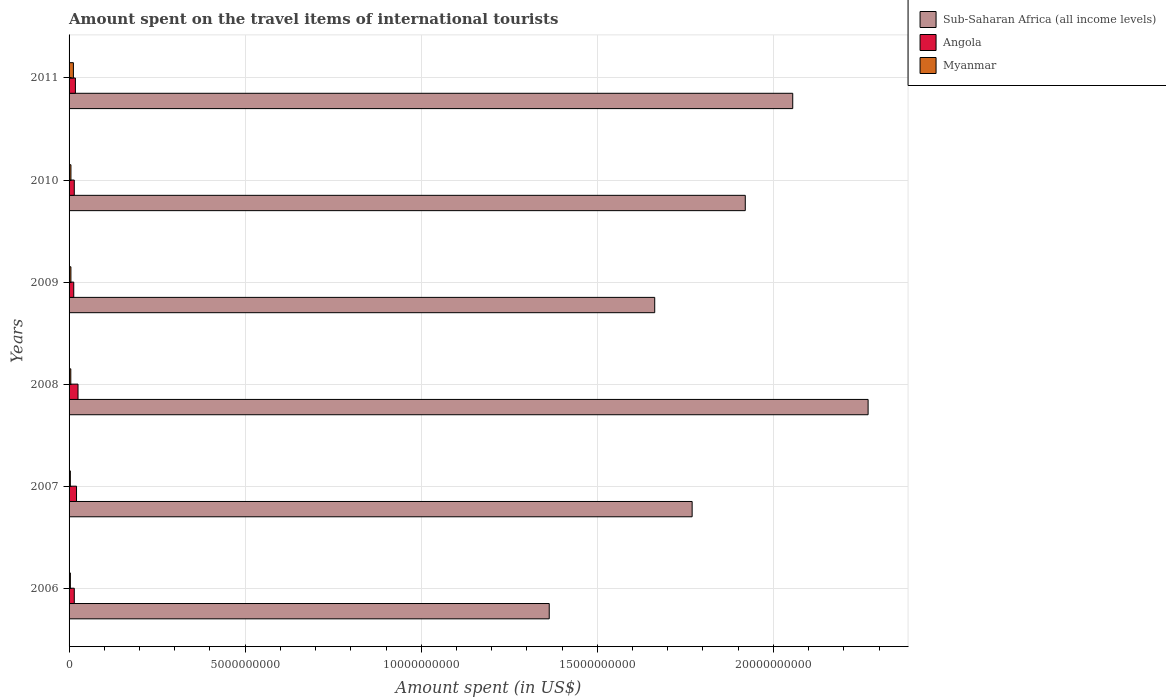How many different coloured bars are there?
Offer a very short reply. 3. How many groups of bars are there?
Ensure brevity in your answer.  6. How many bars are there on the 3rd tick from the top?
Ensure brevity in your answer.  3. How many bars are there on the 1st tick from the bottom?
Offer a very short reply. 3. What is the label of the 6th group of bars from the top?
Provide a short and direct response. 2006. In how many cases, is the number of bars for a given year not equal to the number of legend labels?
Offer a terse response. 0. What is the amount spent on the travel items of international tourists in Sub-Saharan Africa (all income levels) in 2008?
Your answer should be compact. 2.27e+1. Across all years, what is the maximum amount spent on the travel items of international tourists in Sub-Saharan Africa (all income levels)?
Your answer should be very brief. 2.27e+1. Across all years, what is the minimum amount spent on the travel items of international tourists in Sub-Saharan Africa (all income levels)?
Ensure brevity in your answer.  1.36e+1. In which year was the amount spent on the travel items of international tourists in Angola maximum?
Give a very brief answer. 2008. In which year was the amount spent on the travel items of international tourists in Sub-Saharan Africa (all income levels) minimum?
Provide a succinct answer. 2006. What is the total amount spent on the travel items of international tourists in Angola in the graph?
Ensure brevity in your answer.  1.08e+09. What is the difference between the amount spent on the travel items of international tourists in Angola in 2006 and that in 2011?
Give a very brief answer. -3.20e+07. What is the difference between the amount spent on the travel items of international tourists in Myanmar in 2011 and the amount spent on the travel items of international tourists in Angola in 2007?
Give a very brief answer. -8.90e+07. What is the average amount spent on the travel items of international tourists in Sub-Saharan Africa (all income levels) per year?
Your answer should be compact. 1.84e+1. In the year 2009, what is the difference between the amount spent on the travel items of international tourists in Sub-Saharan Africa (all income levels) and amount spent on the travel items of international tourists in Angola?
Your answer should be very brief. 1.65e+1. What is the ratio of the amount spent on the travel items of international tourists in Angola in 2008 to that in 2009?
Keep it short and to the point. 1.91. Is the amount spent on the travel items of international tourists in Sub-Saharan Africa (all income levels) in 2006 less than that in 2007?
Offer a terse response. Yes. What is the difference between the highest and the second highest amount spent on the travel items of international tourists in Angola?
Keep it short and to the point. 4.20e+07. What is the difference between the highest and the lowest amount spent on the travel items of international tourists in Angola?
Offer a very short reply. 1.21e+08. In how many years, is the amount spent on the travel items of international tourists in Angola greater than the average amount spent on the travel items of international tourists in Angola taken over all years?
Give a very brief answer. 3. What does the 3rd bar from the top in 2008 represents?
Give a very brief answer. Sub-Saharan Africa (all income levels). What does the 2nd bar from the bottom in 2011 represents?
Make the answer very short. Angola. Is it the case that in every year, the sum of the amount spent on the travel items of international tourists in Myanmar and amount spent on the travel items of international tourists in Angola is greater than the amount spent on the travel items of international tourists in Sub-Saharan Africa (all income levels)?
Keep it short and to the point. No. How many bars are there?
Make the answer very short. 18. Are all the bars in the graph horizontal?
Make the answer very short. Yes. What is the difference between two consecutive major ticks on the X-axis?
Provide a succinct answer. 5.00e+09. Are the values on the major ticks of X-axis written in scientific E-notation?
Your answer should be very brief. No. Does the graph contain any zero values?
Offer a very short reply. No. How many legend labels are there?
Make the answer very short. 3. What is the title of the graph?
Your answer should be very brief. Amount spent on the travel items of international tourists. What is the label or title of the X-axis?
Give a very brief answer. Amount spent (in US$). What is the label or title of the Y-axis?
Provide a short and direct response. Years. What is the Amount spent (in US$) of Sub-Saharan Africa (all income levels) in 2006?
Keep it short and to the point. 1.36e+1. What is the Amount spent (in US$) in Angola in 2006?
Your response must be concise. 1.48e+08. What is the Amount spent (in US$) of Myanmar in 2006?
Your answer should be compact. 3.70e+07. What is the Amount spent (in US$) of Sub-Saharan Africa (all income levels) in 2007?
Your answer should be compact. 1.77e+1. What is the Amount spent (in US$) of Angola in 2007?
Offer a terse response. 2.12e+08. What is the Amount spent (in US$) of Myanmar in 2007?
Provide a short and direct response. 3.60e+07. What is the Amount spent (in US$) of Sub-Saharan Africa (all income levels) in 2008?
Provide a short and direct response. 2.27e+1. What is the Amount spent (in US$) in Angola in 2008?
Your response must be concise. 2.54e+08. What is the Amount spent (in US$) of Myanmar in 2008?
Give a very brief answer. 4.90e+07. What is the Amount spent (in US$) in Sub-Saharan Africa (all income levels) in 2009?
Ensure brevity in your answer.  1.66e+1. What is the Amount spent (in US$) of Angola in 2009?
Ensure brevity in your answer.  1.33e+08. What is the Amount spent (in US$) in Myanmar in 2009?
Give a very brief answer. 5.20e+07. What is the Amount spent (in US$) in Sub-Saharan Africa (all income levels) in 2010?
Keep it short and to the point. 1.92e+1. What is the Amount spent (in US$) of Angola in 2010?
Ensure brevity in your answer.  1.48e+08. What is the Amount spent (in US$) of Myanmar in 2010?
Your response must be concise. 5.30e+07. What is the Amount spent (in US$) in Sub-Saharan Africa (all income levels) in 2011?
Give a very brief answer. 2.06e+1. What is the Amount spent (in US$) in Angola in 2011?
Your answer should be compact. 1.80e+08. What is the Amount spent (in US$) in Myanmar in 2011?
Provide a succinct answer. 1.23e+08. Across all years, what is the maximum Amount spent (in US$) in Sub-Saharan Africa (all income levels)?
Offer a very short reply. 2.27e+1. Across all years, what is the maximum Amount spent (in US$) of Angola?
Your response must be concise. 2.54e+08. Across all years, what is the maximum Amount spent (in US$) in Myanmar?
Provide a succinct answer. 1.23e+08. Across all years, what is the minimum Amount spent (in US$) of Sub-Saharan Africa (all income levels)?
Give a very brief answer. 1.36e+1. Across all years, what is the minimum Amount spent (in US$) of Angola?
Your answer should be very brief. 1.33e+08. Across all years, what is the minimum Amount spent (in US$) of Myanmar?
Make the answer very short. 3.60e+07. What is the total Amount spent (in US$) of Sub-Saharan Africa (all income levels) in the graph?
Offer a terse response. 1.10e+11. What is the total Amount spent (in US$) in Angola in the graph?
Offer a terse response. 1.08e+09. What is the total Amount spent (in US$) of Myanmar in the graph?
Offer a very short reply. 3.50e+08. What is the difference between the Amount spent (in US$) in Sub-Saharan Africa (all income levels) in 2006 and that in 2007?
Your response must be concise. -4.06e+09. What is the difference between the Amount spent (in US$) in Angola in 2006 and that in 2007?
Offer a very short reply. -6.40e+07. What is the difference between the Amount spent (in US$) of Sub-Saharan Africa (all income levels) in 2006 and that in 2008?
Offer a very short reply. -9.06e+09. What is the difference between the Amount spent (in US$) in Angola in 2006 and that in 2008?
Make the answer very short. -1.06e+08. What is the difference between the Amount spent (in US$) in Myanmar in 2006 and that in 2008?
Your answer should be very brief. -1.20e+07. What is the difference between the Amount spent (in US$) in Sub-Saharan Africa (all income levels) in 2006 and that in 2009?
Your answer should be very brief. -3.00e+09. What is the difference between the Amount spent (in US$) in Angola in 2006 and that in 2009?
Keep it short and to the point. 1.50e+07. What is the difference between the Amount spent (in US$) of Myanmar in 2006 and that in 2009?
Provide a succinct answer. -1.50e+07. What is the difference between the Amount spent (in US$) in Sub-Saharan Africa (all income levels) in 2006 and that in 2010?
Provide a succinct answer. -5.57e+09. What is the difference between the Amount spent (in US$) in Angola in 2006 and that in 2010?
Provide a succinct answer. 0. What is the difference between the Amount spent (in US$) of Myanmar in 2006 and that in 2010?
Offer a terse response. -1.60e+07. What is the difference between the Amount spent (in US$) in Sub-Saharan Africa (all income levels) in 2006 and that in 2011?
Offer a very short reply. -6.92e+09. What is the difference between the Amount spent (in US$) of Angola in 2006 and that in 2011?
Your answer should be very brief. -3.20e+07. What is the difference between the Amount spent (in US$) in Myanmar in 2006 and that in 2011?
Offer a very short reply. -8.60e+07. What is the difference between the Amount spent (in US$) in Sub-Saharan Africa (all income levels) in 2007 and that in 2008?
Your answer should be compact. -5.00e+09. What is the difference between the Amount spent (in US$) in Angola in 2007 and that in 2008?
Provide a short and direct response. -4.20e+07. What is the difference between the Amount spent (in US$) of Myanmar in 2007 and that in 2008?
Make the answer very short. -1.30e+07. What is the difference between the Amount spent (in US$) of Sub-Saharan Africa (all income levels) in 2007 and that in 2009?
Your answer should be compact. 1.06e+09. What is the difference between the Amount spent (in US$) in Angola in 2007 and that in 2009?
Make the answer very short. 7.90e+07. What is the difference between the Amount spent (in US$) of Myanmar in 2007 and that in 2009?
Offer a terse response. -1.60e+07. What is the difference between the Amount spent (in US$) in Sub-Saharan Africa (all income levels) in 2007 and that in 2010?
Offer a very short reply. -1.51e+09. What is the difference between the Amount spent (in US$) in Angola in 2007 and that in 2010?
Make the answer very short. 6.40e+07. What is the difference between the Amount spent (in US$) in Myanmar in 2007 and that in 2010?
Provide a short and direct response. -1.70e+07. What is the difference between the Amount spent (in US$) in Sub-Saharan Africa (all income levels) in 2007 and that in 2011?
Offer a very short reply. -2.86e+09. What is the difference between the Amount spent (in US$) of Angola in 2007 and that in 2011?
Provide a succinct answer. 3.20e+07. What is the difference between the Amount spent (in US$) of Myanmar in 2007 and that in 2011?
Offer a terse response. -8.70e+07. What is the difference between the Amount spent (in US$) in Sub-Saharan Africa (all income levels) in 2008 and that in 2009?
Offer a very short reply. 6.06e+09. What is the difference between the Amount spent (in US$) in Angola in 2008 and that in 2009?
Ensure brevity in your answer.  1.21e+08. What is the difference between the Amount spent (in US$) of Sub-Saharan Africa (all income levels) in 2008 and that in 2010?
Give a very brief answer. 3.49e+09. What is the difference between the Amount spent (in US$) in Angola in 2008 and that in 2010?
Your answer should be very brief. 1.06e+08. What is the difference between the Amount spent (in US$) in Myanmar in 2008 and that in 2010?
Make the answer very short. -4.00e+06. What is the difference between the Amount spent (in US$) in Sub-Saharan Africa (all income levels) in 2008 and that in 2011?
Your answer should be very brief. 2.14e+09. What is the difference between the Amount spent (in US$) of Angola in 2008 and that in 2011?
Offer a terse response. 7.40e+07. What is the difference between the Amount spent (in US$) of Myanmar in 2008 and that in 2011?
Your answer should be compact. -7.40e+07. What is the difference between the Amount spent (in US$) of Sub-Saharan Africa (all income levels) in 2009 and that in 2010?
Offer a very short reply. -2.57e+09. What is the difference between the Amount spent (in US$) of Angola in 2009 and that in 2010?
Provide a short and direct response. -1.50e+07. What is the difference between the Amount spent (in US$) of Sub-Saharan Africa (all income levels) in 2009 and that in 2011?
Offer a terse response. -3.92e+09. What is the difference between the Amount spent (in US$) in Angola in 2009 and that in 2011?
Provide a succinct answer. -4.70e+07. What is the difference between the Amount spent (in US$) of Myanmar in 2009 and that in 2011?
Make the answer very short. -7.10e+07. What is the difference between the Amount spent (in US$) of Sub-Saharan Africa (all income levels) in 2010 and that in 2011?
Your response must be concise. -1.35e+09. What is the difference between the Amount spent (in US$) in Angola in 2010 and that in 2011?
Offer a very short reply. -3.20e+07. What is the difference between the Amount spent (in US$) in Myanmar in 2010 and that in 2011?
Offer a terse response. -7.00e+07. What is the difference between the Amount spent (in US$) of Sub-Saharan Africa (all income levels) in 2006 and the Amount spent (in US$) of Angola in 2007?
Provide a succinct answer. 1.34e+1. What is the difference between the Amount spent (in US$) of Sub-Saharan Africa (all income levels) in 2006 and the Amount spent (in US$) of Myanmar in 2007?
Offer a very short reply. 1.36e+1. What is the difference between the Amount spent (in US$) in Angola in 2006 and the Amount spent (in US$) in Myanmar in 2007?
Your response must be concise. 1.12e+08. What is the difference between the Amount spent (in US$) in Sub-Saharan Africa (all income levels) in 2006 and the Amount spent (in US$) in Angola in 2008?
Provide a short and direct response. 1.34e+1. What is the difference between the Amount spent (in US$) in Sub-Saharan Africa (all income levels) in 2006 and the Amount spent (in US$) in Myanmar in 2008?
Offer a terse response. 1.36e+1. What is the difference between the Amount spent (in US$) of Angola in 2006 and the Amount spent (in US$) of Myanmar in 2008?
Make the answer very short. 9.90e+07. What is the difference between the Amount spent (in US$) in Sub-Saharan Africa (all income levels) in 2006 and the Amount spent (in US$) in Angola in 2009?
Make the answer very short. 1.35e+1. What is the difference between the Amount spent (in US$) in Sub-Saharan Africa (all income levels) in 2006 and the Amount spent (in US$) in Myanmar in 2009?
Provide a succinct answer. 1.36e+1. What is the difference between the Amount spent (in US$) of Angola in 2006 and the Amount spent (in US$) of Myanmar in 2009?
Your answer should be very brief. 9.60e+07. What is the difference between the Amount spent (in US$) in Sub-Saharan Africa (all income levels) in 2006 and the Amount spent (in US$) in Angola in 2010?
Keep it short and to the point. 1.35e+1. What is the difference between the Amount spent (in US$) in Sub-Saharan Africa (all income levels) in 2006 and the Amount spent (in US$) in Myanmar in 2010?
Make the answer very short. 1.36e+1. What is the difference between the Amount spent (in US$) of Angola in 2006 and the Amount spent (in US$) of Myanmar in 2010?
Give a very brief answer. 9.50e+07. What is the difference between the Amount spent (in US$) in Sub-Saharan Africa (all income levels) in 2006 and the Amount spent (in US$) in Angola in 2011?
Your answer should be very brief. 1.35e+1. What is the difference between the Amount spent (in US$) in Sub-Saharan Africa (all income levels) in 2006 and the Amount spent (in US$) in Myanmar in 2011?
Provide a succinct answer. 1.35e+1. What is the difference between the Amount spent (in US$) of Angola in 2006 and the Amount spent (in US$) of Myanmar in 2011?
Give a very brief answer. 2.50e+07. What is the difference between the Amount spent (in US$) in Sub-Saharan Africa (all income levels) in 2007 and the Amount spent (in US$) in Angola in 2008?
Provide a short and direct response. 1.74e+1. What is the difference between the Amount spent (in US$) in Sub-Saharan Africa (all income levels) in 2007 and the Amount spent (in US$) in Myanmar in 2008?
Offer a terse response. 1.76e+1. What is the difference between the Amount spent (in US$) of Angola in 2007 and the Amount spent (in US$) of Myanmar in 2008?
Give a very brief answer. 1.63e+08. What is the difference between the Amount spent (in US$) in Sub-Saharan Africa (all income levels) in 2007 and the Amount spent (in US$) in Angola in 2009?
Offer a terse response. 1.76e+1. What is the difference between the Amount spent (in US$) of Sub-Saharan Africa (all income levels) in 2007 and the Amount spent (in US$) of Myanmar in 2009?
Keep it short and to the point. 1.76e+1. What is the difference between the Amount spent (in US$) in Angola in 2007 and the Amount spent (in US$) in Myanmar in 2009?
Ensure brevity in your answer.  1.60e+08. What is the difference between the Amount spent (in US$) in Sub-Saharan Africa (all income levels) in 2007 and the Amount spent (in US$) in Angola in 2010?
Your answer should be very brief. 1.75e+1. What is the difference between the Amount spent (in US$) in Sub-Saharan Africa (all income levels) in 2007 and the Amount spent (in US$) in Myanmar in 2010?
Give a very brief answer. 1.76e+1. What is the difference between the Amount spent (in US$) in Angola in 2007 and the Amount spent (in US$) in Myanmar in 2010?
Your response must be concise. 1.59e+08. What is the difference between the Amount spent (in US$) of Sub-Saharan Africa (all income levels) in 2007 and the Amount spent (in US$) of Angola in 2011?
Your response must be concise. 1.75e+1. What is the difference between the Amount spent (in US$) in Sub-Saharan Africa (all income levels) in 2007 and the Amount spent (in US$) in Myanmar in 2011?
Offer a terse response. 1.76e+1. What is the difference between the Amount spent (in US$) of Angola in 2007 and the Amount spent (in US$) of Myanmar in 2011?
Your response must be concise. 8.90e+07. What is the difference between the Amount spent (in US$) of Sub-Saharan Africa (all income levels) in 2008 and the Amount spent (in US$) of Angola in 2009?
Your answer should be very brief. 2.26e+1. What is the difference between the Amount spent (in US$) in Sub-Saharan Africa (all income levels) in 2008 and the Amount spent (in US$) in Myanmar in 2009?
Your answer should be very brief. 2.26e+1. What is the difference between the Amount spent (in US$) in Angola in 2008 and the Amount spent (in US$) in Myanmar in 2009?
Provide a succinct answer. 2.02e+08. What is the difference between the Amount spent (in US$) of Sub-Saharan Africa (all income levels) in 2008 and the Amount spent (in US$) of Angola in 2010?
Your answer should be compact. 2.25e+1. What is the difference between the Amount spent (in US$) of Sub-Saharan Africa (all income levels) in 2008 and the Amount spent (in US$) of Myanmar in 2010?
Provide a short and direct response. 2.26e+1. What is the difference between the Amount spent (in US$) in Angola in 2008 and the Amount spent (in US$) in Myanmar in 2010?
Offer a very short reply. 2.01e+08. What is the difference between the Amount spent (in US$) in Sub-Saharan Africa (all income levels) in 2008 and the Amount spent (in US$) in Angola in 2011?
Keep it short and to the point. 2.25e+1. What is the difference between the Amount spent (in US$) in Sub-Saharan Africa (all income levels) in 2008 and the Amount spent (in US$) in Myanmar in 2011?
Keep it short and to the point. 2.26e+1. What is the difference between the Amount spent (in US$) in Angola in 2008 and the Amount spent (in US$) in Myanmar in 2011?
Keep it short and to the point. 1.31e+08. What is the difference between the Amount spent (in US$) of Sub-Saharan Africa (all income levels) in 2009 and the Amount spent (in US$) of Angola in 2010?
Provide a succinct answer. 1.65e+1. What is the difference between the Amount spent (in US$) in Sub-Saharan Africa (all income levels) in 2009 and the Amount spent (in US$) in Myanmar in 2010?
Make the answer very short. 1.66e+1. What is the difference between the Amount spent (in US$) of Angola in 2009 and the Amount spent (in US$) of Myanmar in 2010?
Your response must be concise. 8.00e+07. What is the difference between the Amount spent (in US$) in Sub-Saharan Africa (all income levels) in 2009 and the Amount spent (in US$) in Angola in 2011?
Make the answer very short. 1.65e+1. What is the difference between the Amount spent (in US$) of Sub-Saharan Africa (all income levels) in 2009 and the Amount spent (in US$) of Myanmar in 2011?
Your answer should be compact. 1.65e+1. What is the difference between the Amount spent (in US$) of Angola in 2009 and the Amount spent (in US$) of Myanmar in 2011?
Ensure brevity in your answer.  1.00e+07. What is the difference between the Amount spent (in US$) of Sub-Saharan Africa (all income levels) in 2010 and the Amount spent (in US$) of Angola in 2011?
Give a very brief answer. 1.90e+1. What is the difference between the Amount spent (in US$) in Sub-Saharan Africa (all income levels) in 2010 and the Amount spent (in US$) in Myanmar in 2011?
Keep it short and to the point. 1.91e+1. What is the difference between the Amount spent (in US$) of Angola in 2010 and the Amount spent (in US$) of Myanmar in 2011?
Provide a succinct answer. 2.50e+07. What is the average Amount spent (in US$) in Sub-Saharan Africa (all income levels) per year?
Make the answer very short. 1.84e+1. What is the average Amount spent (in US$) of Angola per year?
Your response must be concise. 1.79e+08. What is the average Amount spent (in US$) of Myanmar per year?
Provide a succinct answer. 5.83e+07. In the year 2006, what is the difference between the Amount spent (in US$) in Sub-Saharan Africa (all income levels) and Amount spent (in US$) in Angola?
Ensure brevity in your answer.  1.35e+1. In the year 2006, what is the difference between the Amount spent (in US$) in Sub-Saharan Africa (all income levels) and Amount spent (in US$) in Myanmar?
Make the answer very short. 1.36e+1. In the year 2006, what is the difference between the Amount spent (in US$) in Angola and Amount spent (in US$) in Myanmar?
Offer a terse response. 1.11e+08. In the year 2007, what is the difference between the Amount spent (in US$) of Sub-Saharan Africa (all income levels) and Amount spent (in US$) of Angola?
Your answer should be compact. 1.75e+1. In the year 2007, what is the difference between the Amount spent (in US$) in Sub-Saharan Africa (all income levels) and Amount spent (in US$) in Myanmar?
Give a very brief answer. 1.77e+1. In the year 2007, what is the difference between the Amount spent (in US$) in Angola and Amount spent (in US$) in Myanmar?
Offer a terse response. 1.76e+08. In the year 2008, what is the difference between the Amount spent (in US$) in Sub-Saharan Africa (all income levels) and Amount spent (in US$) in Angola?
Your response must be concise. 2.24e+1. In the year 2008, what is the difference between the Amount spent (in US$) in Sub-Saharan Africa (all income levels) and Amount spent (in US$) in Myanmar?
Make the answer very short. 2.26e+1. In the year 2008, what is the difference between the Amount spent (in US$) in Angola and Amount spent (in US$) in Myanmar?
Provide a succinct answer. 2.05e+08. In the year 2009, what is the difference between the Amount spent (in US$) in Sub-Saharan Africa (all income levels) and Amount spent (in US$) in Angola?
Make the answer very short. 1.65e+1. In the year 2009, what is the difference between the Amount spent (in US$) of Sub-Saharan Africa (all income levels) and Amount spent (in US$) of Myanmar?
Your answer should be very brief. 1.66e+1. In the year 2009, what is the difference between the Amount spent (in US$) in Angola and Amount spent (in US$) in Myanmar?
Offer a very short reply. 8.10e+07. In the year 2010, what is the difference between the Amount spent (in US$) of Sub-Saharan Africa (all income levels) and Amount spent (in US$) of Angola?
Make the answer very short. 1.91e+1. In the year 2010, what is the difference between the Amount spent (in US$) in Sub-Saharan Africa (all income levels) and Amount spent (in US$) in Myanmar?
Your answer should be compact. 1.91e+1. In the year 2010, what is the difference between the Amount spent (in US$) of Angola and Amount spent (in US$) of Myanmar?
Your answer should be compact. 9.50e+07. In the year 2011, what is the difference between the Amount spent (in US$) in Sub-Saharan Africa (all income levels) and Amount spent (in US$) in Angola?
Offer a very short reply. 2.04e+1. In the year 2011, what is the difference between the Amount spent (in US$) in Sub-Saharan Africa (all income levels) and Amount spent (in US$) in Myanmar?
Offer a very short reply. 2.04e+1. In the year 2011, what is the difference between the Amount spent (in US$) in Angola and Amount spent (in US$) in Myanmar?
Keep it short and to the point. 5.70e+07. What is the ratio of the Amount spent (in US$) of Sub-Saharan Africa (all income levels) in 2006 to that in 2007?
Keep it short and to the point. 0.77. What is the ratio of the Amount spent (in US$) of Angola in 2006 to that in 2007?
Your answer should be compact. 0.7. What is the ratio of the Amount spent (in US$) of Myanmar in 2006 to that in 2007?
Offer a very short reply. 1.03. What is the ratio of the Amount spent (in US$) of Sub-Saharan Africa (all income levels) in 2006 to that in 2008?
Offer a terse response. 0.6. What is the ratio of the Amount spent (in US$) of Angola in 2006 to that in 2008?
Make the answer very short. 0.58. What is the ratio of the Amount spent (in US$) of Myanmar in 2006 to that in 2008?
Offer a terse response. 0.76. What is the ratio of the Amount spent (in US$) of Sub-Saharan Africa (all income levels) in 2006 to that in 2009?
Your response must be concise. 0.82. What is the ratio of the Amount spent (in US$) in Angola in 2006 to that in 2009?
Ensure brevity in your answer.  1.11. What is the ratio of the Amount spent (in US$) of Myanmar in 2006 to that in 2009?
Your answer should be compact. 0.71. What is the ratio of the Amount spent (in US$) of Sub-Saharan Africa (all income levels) in 2006 to that in 2010?
Your answer should be compact. 0.71. What is the ratio of the Amount spent (in US$) in Myanmar in 2006 to that in 2010?
Ensure brevity in your answer.  0.7. What is the ratio of the Amount spent (in US$) of Sub-Saharan Africa (all income levels) in 2006 to that in 2011?
Keep it short and to the point. 0.66. What is the ratio of the Amount spent (in US$) in Angola in 2006 to that in 2011?
Provide a succinct answer. 0.82. What is the ratio of the Amount spent (in US$) in Myanmar in 2006 to that in 2011?
Make the answer very short. 0.3. What is the ratio of the Amount spent (in US$) in Sub-Saharan Africa (all income levels) in 2007 to that in 2008?
Keep it short and to the point. 0.78. What is the ratio of the Amount spent (in US$) of Angola in 2007 to that in 2008?
Offer a terse response. 0.83. What is the ratio of the Amount spent (in US$) of Myanmar in 2007 to that in 2008?
Offer a terse response. 0.73. What is the ratio of the Amount spent (in US$) in Sub-Saharan Africa (all income levels) in 2007 to that in 2009?
Offer a very short reply. 1.06. What is the ratio of the Amount spent (in US$) in Angola in 2007 to that in 2009?
Make the answer very short. 1.59. What is the ratio of the Amount spent (in US$) of Myanmar in 2007 to that in 2009?
Your answer should be very brief. 0.69. What is the ratio of the Amount spent (in US$) of Sub-Saharan Africa (all income levels) in 2007 to that in 2010?
Offer a terse response. 0.92. What is the ratio of the Amount spent (in US$) of Angola in 2007 to that in 2010?
Offer a terse response. 1.43. What is the ratio of the Amount spent (in US$) of Myanmar in 2007 to that in 2010?
Keep it short and to the point. 0.68. What is the ratio of the Amount spent (in US$) of Sub-Saharan Africa (all income levels) in 2007 to that in 2011?
Your response must be concise. 0.86. What is the ratio of the Amount spent (in US$) of Angola in 2007 to that in 2011?
Your answer should be compact. 1.18. What is the ratio of the Amount spent (in US$) of Myanmar in 2007 to that in 2011?
Offer a terse response. 0.29. What is the ratio of the Amount spent (in US$) in Sub-Saharan Africa (all income levels) in 2008 to that in 2009?
Your response must be concise. 1.36. What is the ratio of the Amount spent (in US$) in Angola in 2008 to that in 2009?
Your answer should be compact. 1.91. What is the ratio of the Amount spent (in US$) in Myanmar in 2008 to that in 2009?
Give a very brief answer. 0.94. What is the ratio of the Amount spent (in US$) of Sub-Saharan Africa (all income levels) in 2008 to that in 2010?
Give a very brief answer. 1.18. What is the ratio of the Amount spent (in US$) of Angola in 2008 to that in 2010?
Provide a succinct answer. 1.72. What is the ratio of the Amount spent (in US$) in Myanmar in 2008 to that in 2010?
Offer a terse response. 0.92. What is the ratio of the Amount spent (in US$) of Sub-Saharan Africa (all income levels) in 2008 to that in 2011?
Offer a terse response. 1.1. What is the ratio of the Amount spent (in US$) in Angola in 2008 to that in 2011?
Ensure brevity in your answer.  1.41. What is the ratio of the Amount spent (in US$) in Myanmar in 2008 to that in 2011?
Make the answer very short. 0.4. What is the ratio of the Amount spent (in US$) in Sub-Saharan Africa (all income levels) in 2009 to that in 2010?
Your answer should be compact. 0.87. What is the ratio of the Amount spent (in US$) in Angola in 2009 to that in 2010?
Your answer should be compact. 0.9. What is the ratio of the Amount spent (in US$) in Myanmar in 2009 to that in 2010?
Make the answer very short. 0.98. What is the ratio of the Amount spent (in US$) in Sub-Saharan Africa (all income levels) in 2009 to that in 2011?
Ensure brevity in your answer.  0.81. What is the ratio of the Amount spent (in US$) in Angola in 2009 to that in 2011?
Provide a succinct answer. 0.74. What is the ratio of the Amount spent (in US$) in Myanmar in 2009 to that in 2011?
Ensure brevity in your answer.  0.42. What is the ratio of the Amount spent (in US$) of Sub-Saharan Africa (all income levels) in 2010 to that in 2011?
Offer a terse response. 0.93. What is the ratio of the Amount spent (in US$) of Angola in 2010 to that in 2011?
Keep it short and to the point. 0.82. What is the ratio of the Amount spent (in US$) in Myanmar in 2010 to that in 2011?
Your answer should be compact. 0.43. What is the difference between the highest and the second highest Amount spent (in US$) of Sub-Saharan Africa (all income levels)?
Your answer should be very brief. 2.14e+09. What is the difference between the highest and the second highest Amount spent (in US$) in Angola?
Your response must be concise. 4.20e+07. What is the difference between the highest and the second highest Amount spent (in US$) in Myanmar?
Your answer should be compact. 7.00e+07. What is the difference between the highest and the lowest Amount spent (in US$) of Sub-Saharan Africa (all income levels)?
Your answer should be very brief. 9.06e+09. What is the difference between the highest and the lowest Amount spent (in US$) in Angola?
Give a very brief answer. 1.21e+08. What is the difference between the highest and the lowest Amount spent (in US$) in Myanmar?
Your answer should be very brief. 8.70e+07. 